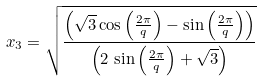Convert formula to latex. <formula><loc_0><loc_0><loc_500><loc_500>x _ { 3 } = \sqrt { \frac { \left ( \sqrt { 3 } \cos \left ( { \frac { 2 \pi } { q } } \right ) - \sin \left ( { \frac { 2 \pi } { q } } \right ) \right ) } { \left ( 2 \, \sin \left ( { \frac { 2 \pi } { q } } \right ) + \sqrt { 3 } \right ) } }</formula> 